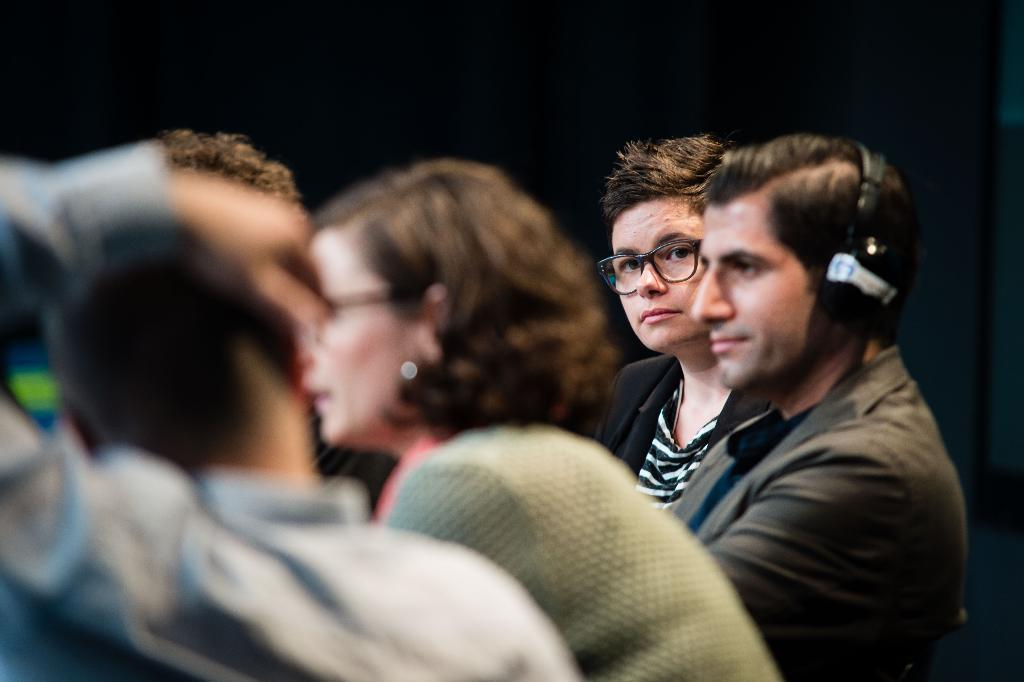How many people are in the image? There is a group of persons in the image. What are the persons wearing in the image? The persons are wearing dresses. Can you describe any accessories worn by the persons? One person is wearing spectacles, and another person is wearing headphones. What type of snow can be seen falling in the image? There is no snow present in the image. How does the flock of birds interact with the persons in the image? There are no birds present in the image, so it is not possible to describe their interaction with the persons. 